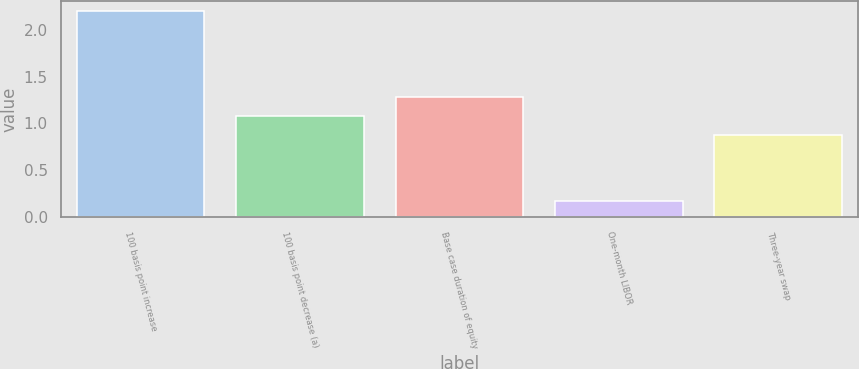<chart> <loc_0><loc_0><loc_500><loc_500><bar_chart><fcel>100 basis point increase<fcel>100 basis point decrease (a)<fcel>Base case duration of equity<fcel>One-month LIBOR<fcel>Three-year swap<nl><fcel>2.2<fcel>1.08<fcel>1.28<fcel>0.17<fcel>0.88<nl></chart> 